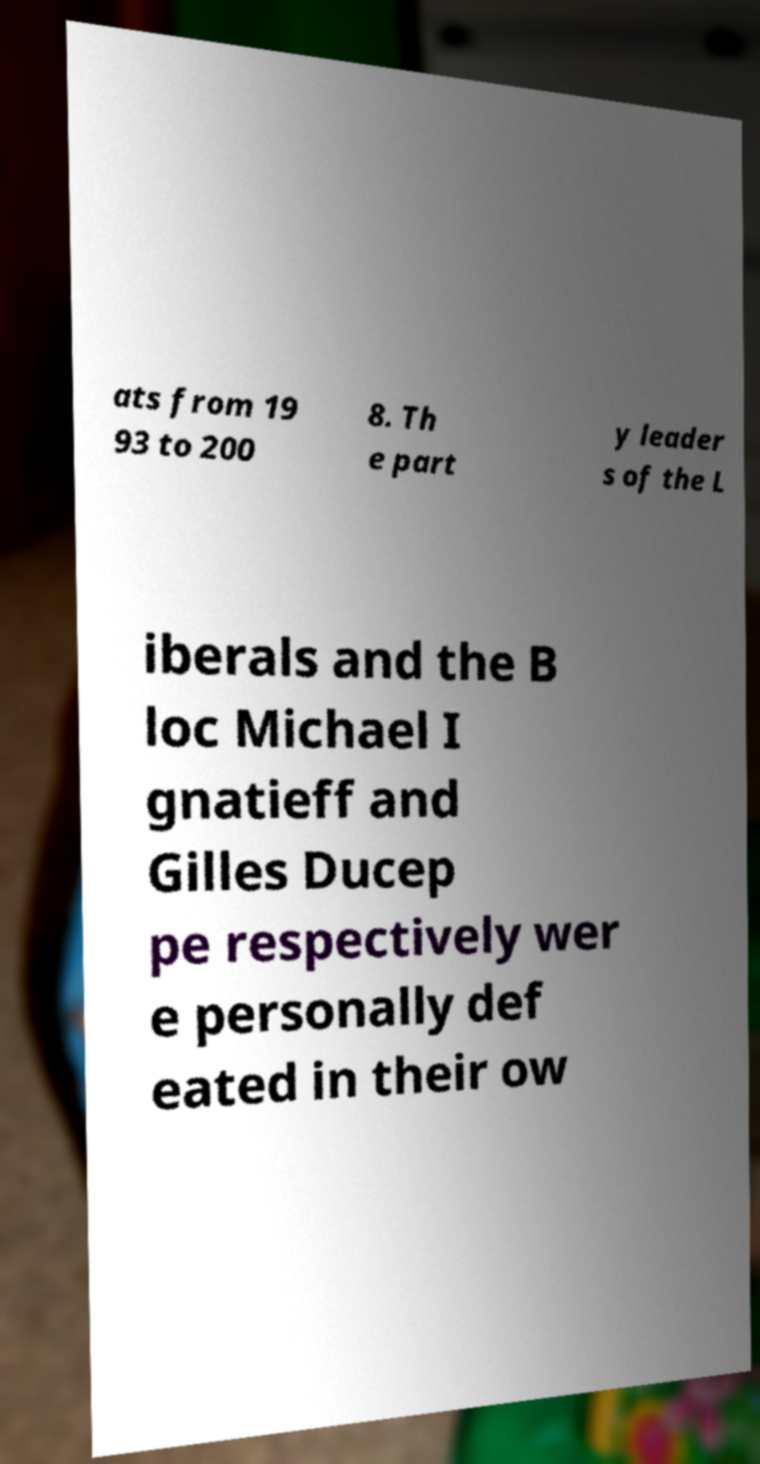Can you read and provide the text displayed in the image?This photo seems to have some interesting text. Can you extract and type it out for me? ats from 19 93 to 200 8. Th e part y leader s of the L iberals and the B loc Michael I gnatieff and Gilles Ducep pe respectively wer e personally def eated in their ow 